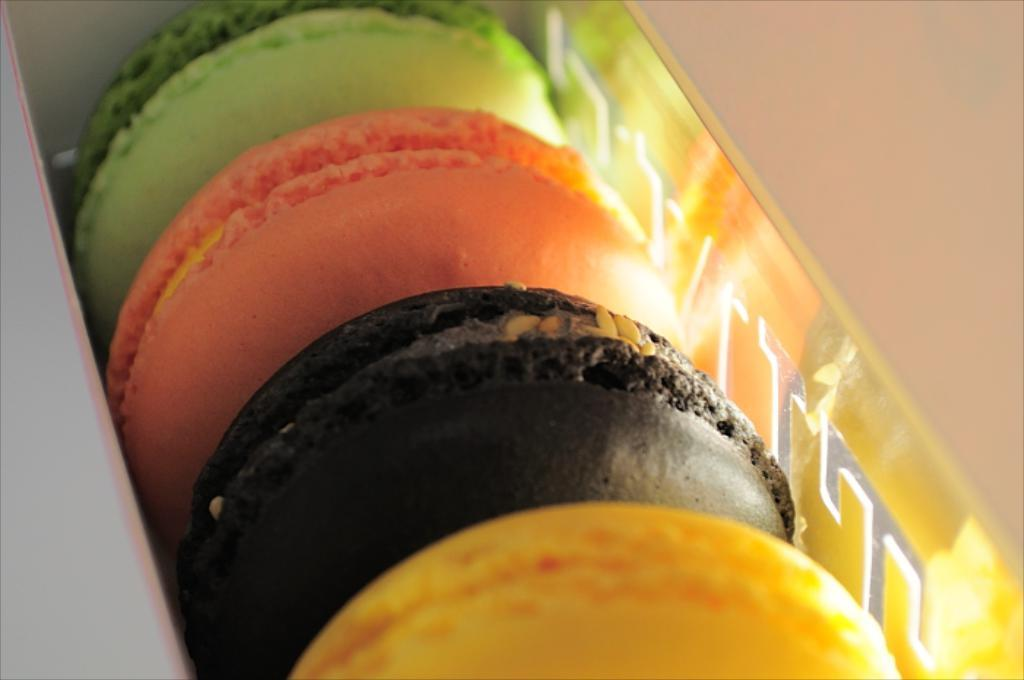What type of food is visible in the image? There are biscuits in the image. What is between the biscuits? There is cream between the biscuits. What can be observed about the biscuits' appearance? The biscuits are in different colors. How are the biscuits arranged or stored in the image? The biscuits are placed in a box. What type of waves can be seen in the image? There are no waves present in the image; it features biscuits with cream between them and placed in a box. How does the laughter sound in the image? There is no laughter present in the image; it only contains biscuits, cream, and a box. 